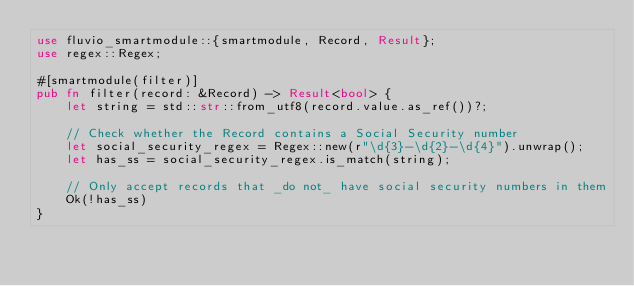<code> <loc_0><loc_0><loc_500><loc_500><_Rust_>use fluvio_smartmodule::{smartmodule, Record, Result};
use regex::Regex;

#[smartmodule(filter)]
pub fn filter(record: &Record) -> Result<bool> {
    let string = std::str::from_utf8(record.value.as_ref())?;

    // Check whether the Record contains a Social Security number
    let social_security_regex = Regex::new(r"\d{3}-\d{2}-\d{4}").unwrap();
    let has_ss = social_security_regex.is_match(string);

    // Only accept records that _do not_ have social security numbers in them
    Ok(!has_ss)
}
</code> 